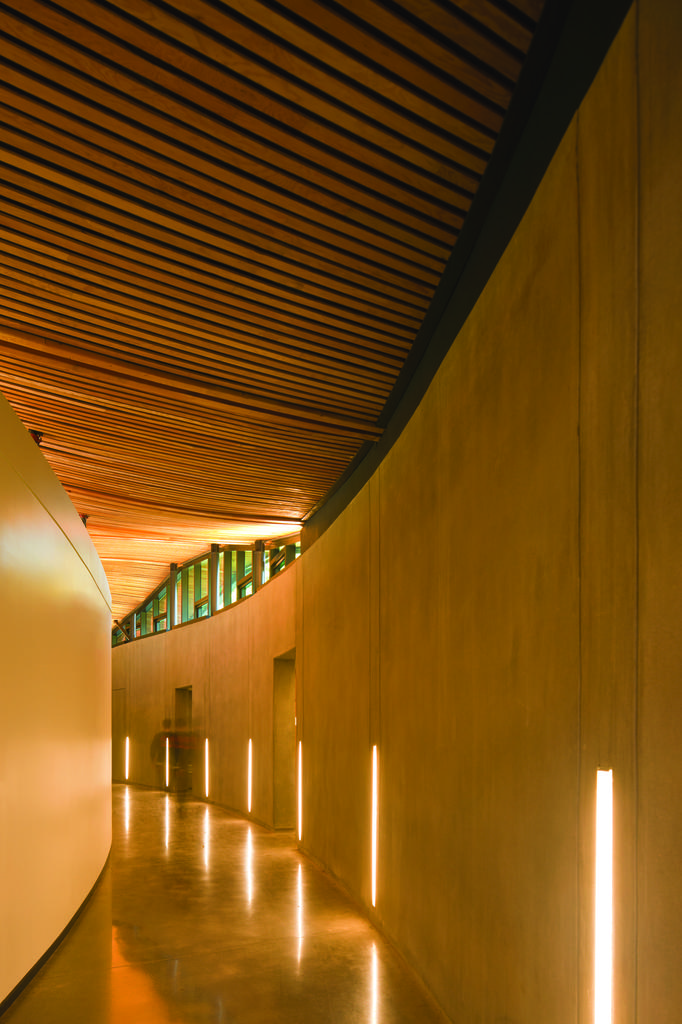What type of location is depicted in the image? The image shows an inside view of a building. What structural elements can be seen in the image? There are walls visible in the image. What can be seen providing illumination in the image? There are lights visible in the image. What surface is visible underfoot in the image? The floor is visible in the image. What type of ray is visible in the image? There is no ray present in the image; it depicts an interior view of a building with walls, lights, and a floor. 